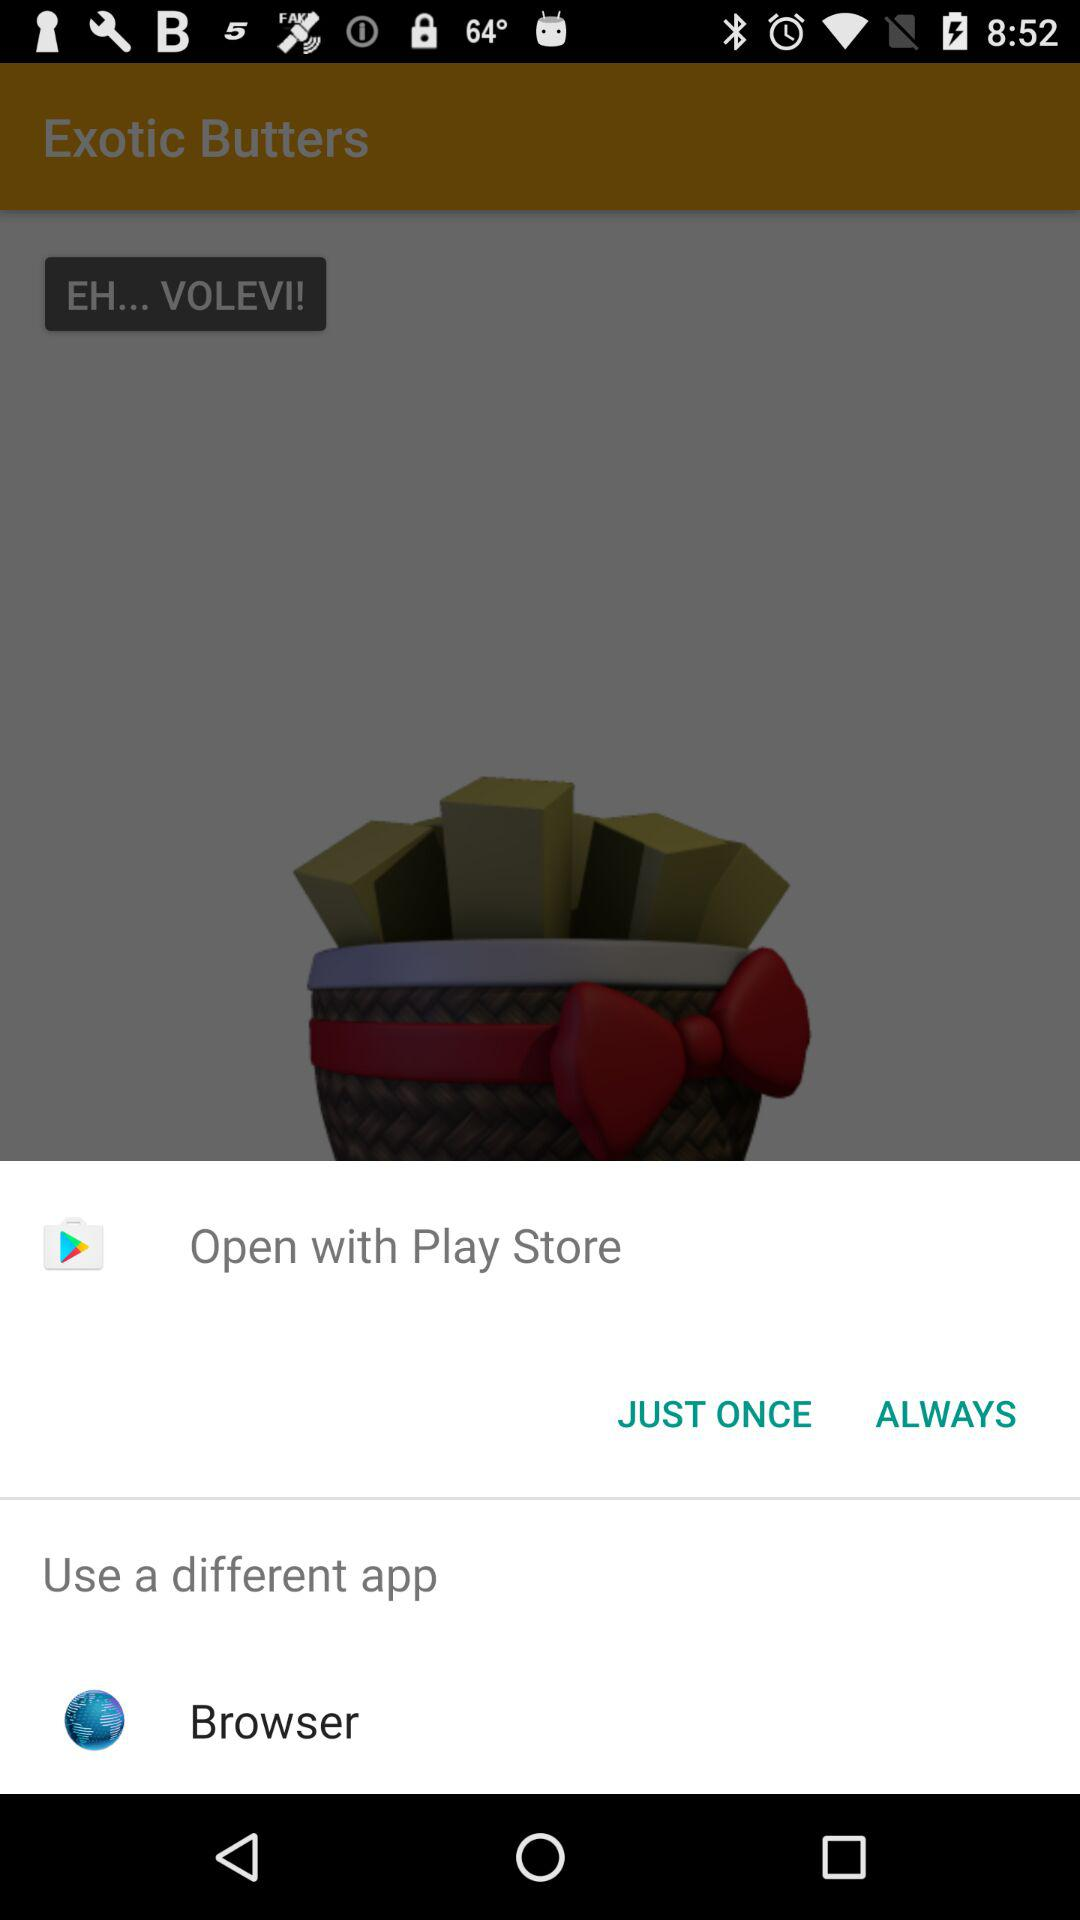How many flavors of exotic butter are there?
When the provided information is insufficient, respond with <no answer>. <no answer> 